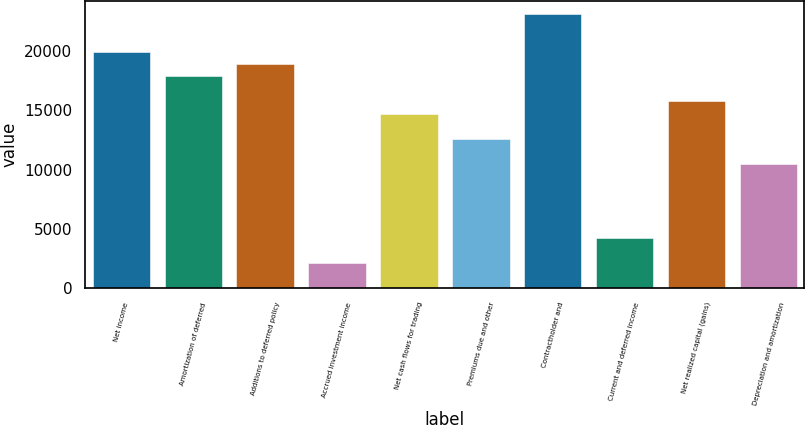Convert chart to OTSL. <chart><loc_0><loc_0><loc_500><loc_500><bar_chart><fcel>Net income<fcel>Amortization of deferred<fcel>Additions to deferred policy<fcel>Accrued investment income<fcel>Net cash flows for trading<fcel>Premiums due and other<fcel>Contractholder and<fcel>Current and deferred income<fcel>Net realized capital (gains)<fcel>Depreciation and amortization<nl><fcel>19949.2<fcel>17853.9<fcel>18901.6<fcel>2139.02<fcel>14710.9<fcel>12615.6<fcel>23092.2<fcel>4234.34<fcel>15758.6<fcel>10520.3<nl></chart> 